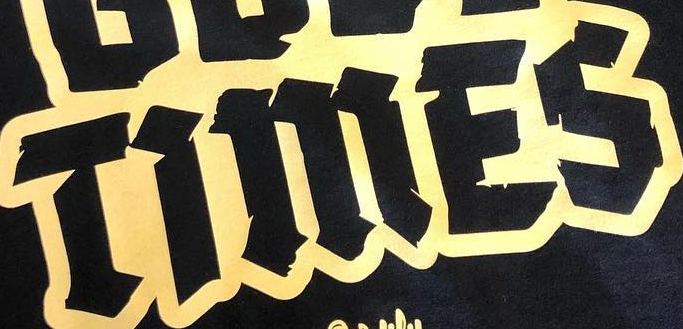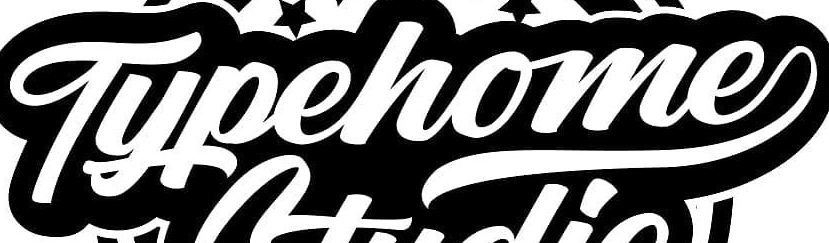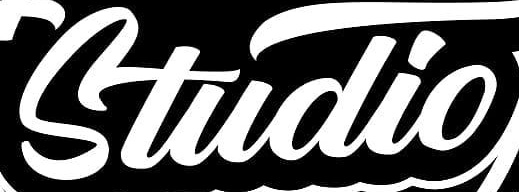What text is displayed in these images sequentially, separated by a semicolon? TiMES; Typehome; Studio 